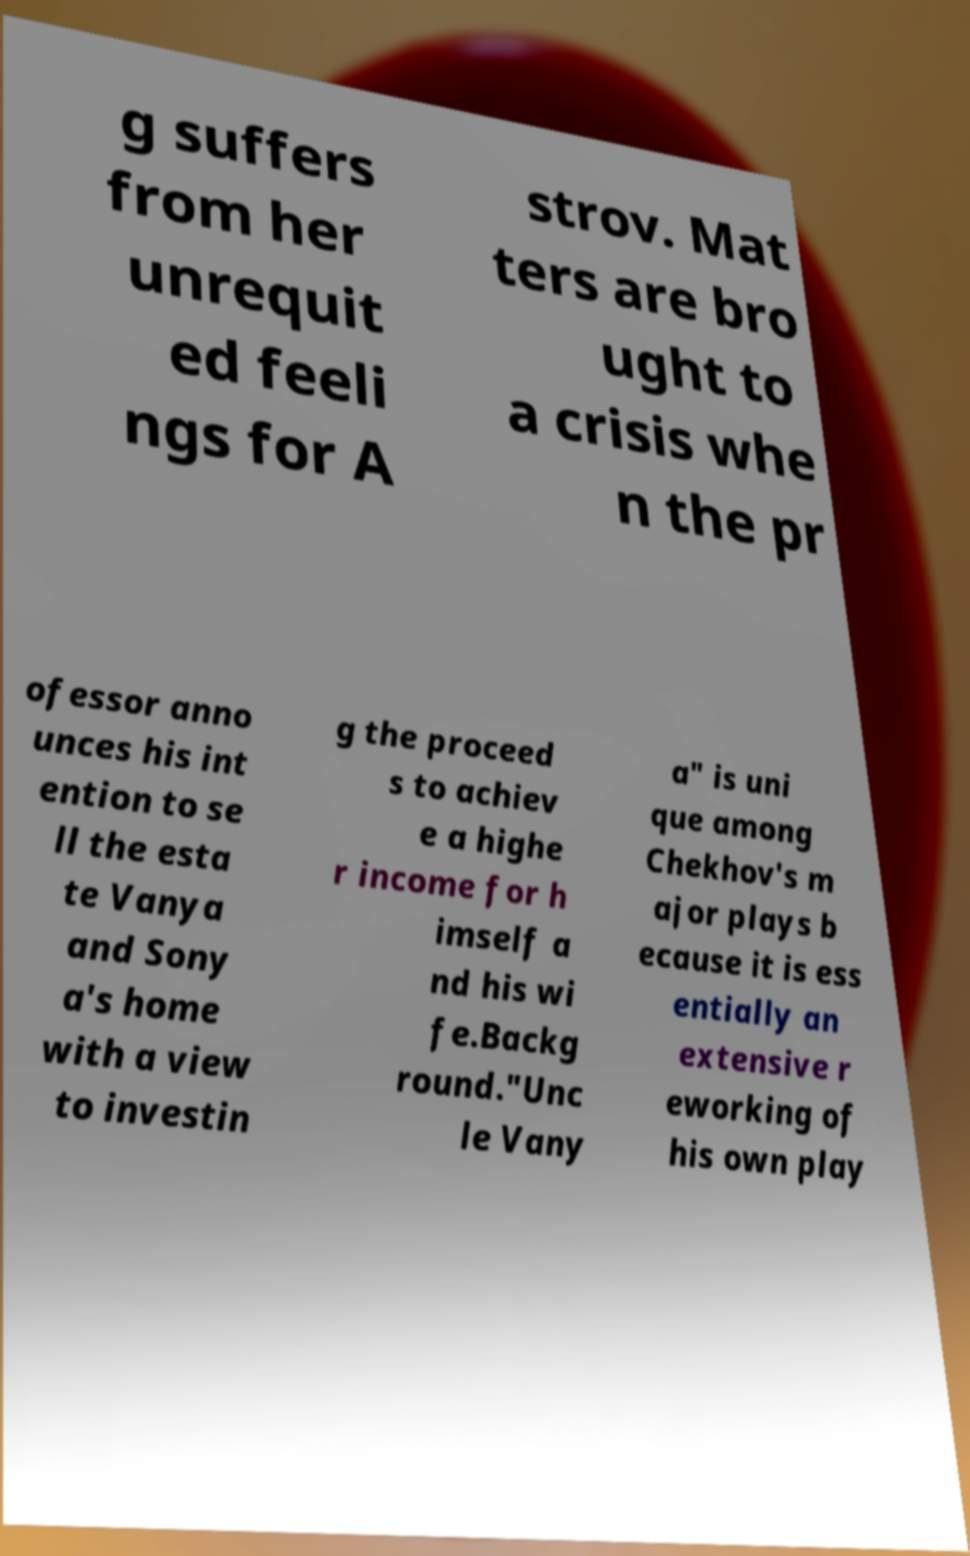Could you assist in decoding the text presented in this image and type it out clearly? g suffers from her unrequit ed feeli ngs for A strov. Mat ters are bro ught to a crisis whe n the pr ofessor anno unces his int ention to se ll the esta te Vanya and Sony a's home with a view to investin g the proceed s to achiev e a highe r income for h imself a nd his wi fe.Backg round."Unc le Vany a" is uni que among Chekhov's m ajor plays b ecause it is ess entially an extensive r eworking of his own play 